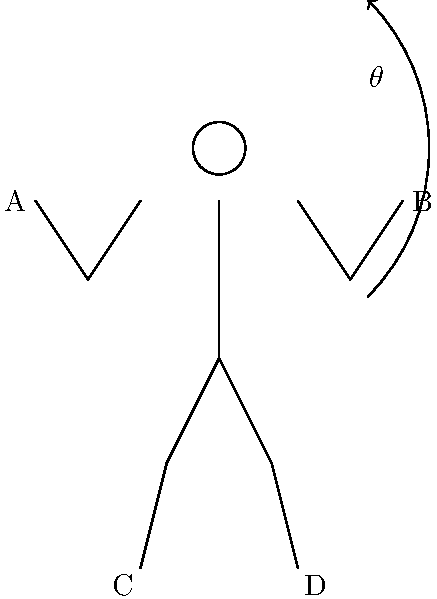In a traditional Cherokee stomp dance, dancers often perform a circular movement with their arms raised. If the stick figure represents a dancer in this position, with point A being the left hand and point B being the right hand, what is the approximate angular velocity (in radians per second) of the arm movement if it takes 2 seconds to complete a full revolution? Assume the movement is uniform circular motion. To solve this problem, we need to follow these steps:

1. Understand that angular velocity ($\omega$) is the rate of change of angular position with respect to time.

2. Recall the formula for angular velocity:
   $\omega = \frac{\Delta \theta}{\Delta t}$

   Where:
   $\Delta \theta$ is the change in angle (in radians)
   $\Delta t$ is the time taken (in seconds)

3. In a full revolution, the change in angle is $2\pi$ radians (360 degrees).

4. The time taken for a full revolution is given as 2 seconds.

5. Substitute these values into the formula:
   $\omega = \frac{2\pi}{2}$

6. Simplify:
   $\omega = \pi$ radians per second

Therefore, the angular velocity of the arm movement is $\pi$ radians per second.
Answer: $\pi$ rad/s 